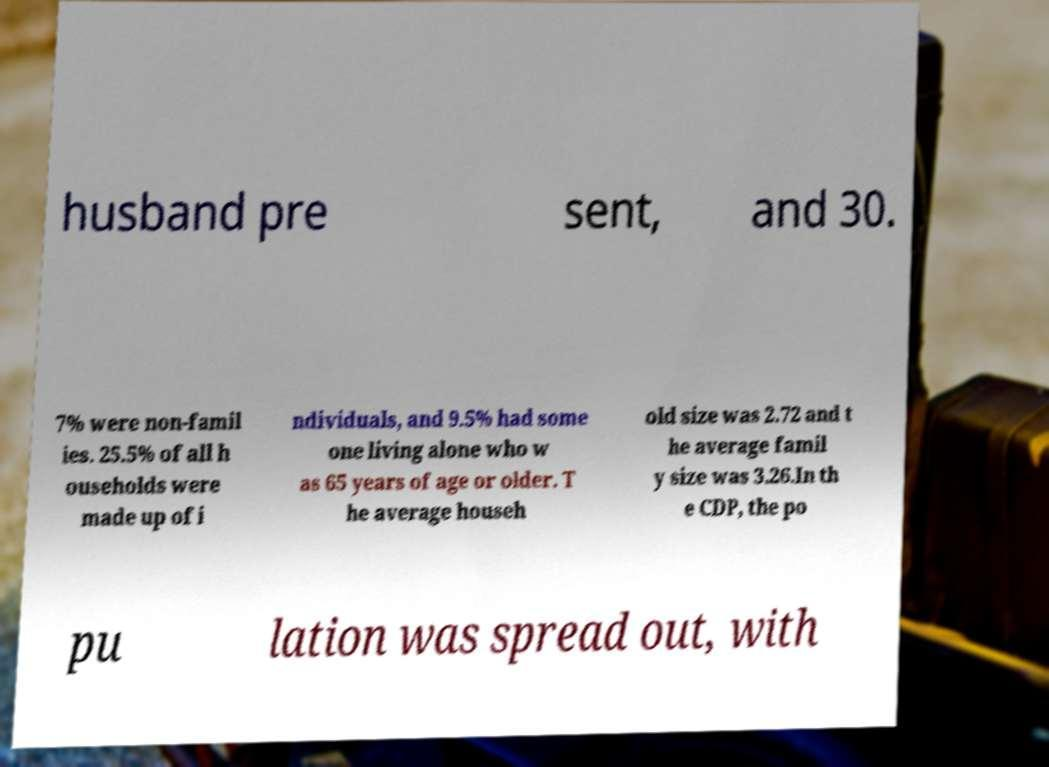Could you assist in decoding the text presented in this image and type it out clearly? husband pre sent, and 30. 7% were non-famil ies. 25.5% of all h ouseholds were made up of i ndividuals, and 9.5% had some one living alone who w as 65 years of age or older. T he average househ old size was 2.72 and t he average famil y size was 3.26.In th e CDP, the po pu lation was spread out, with 